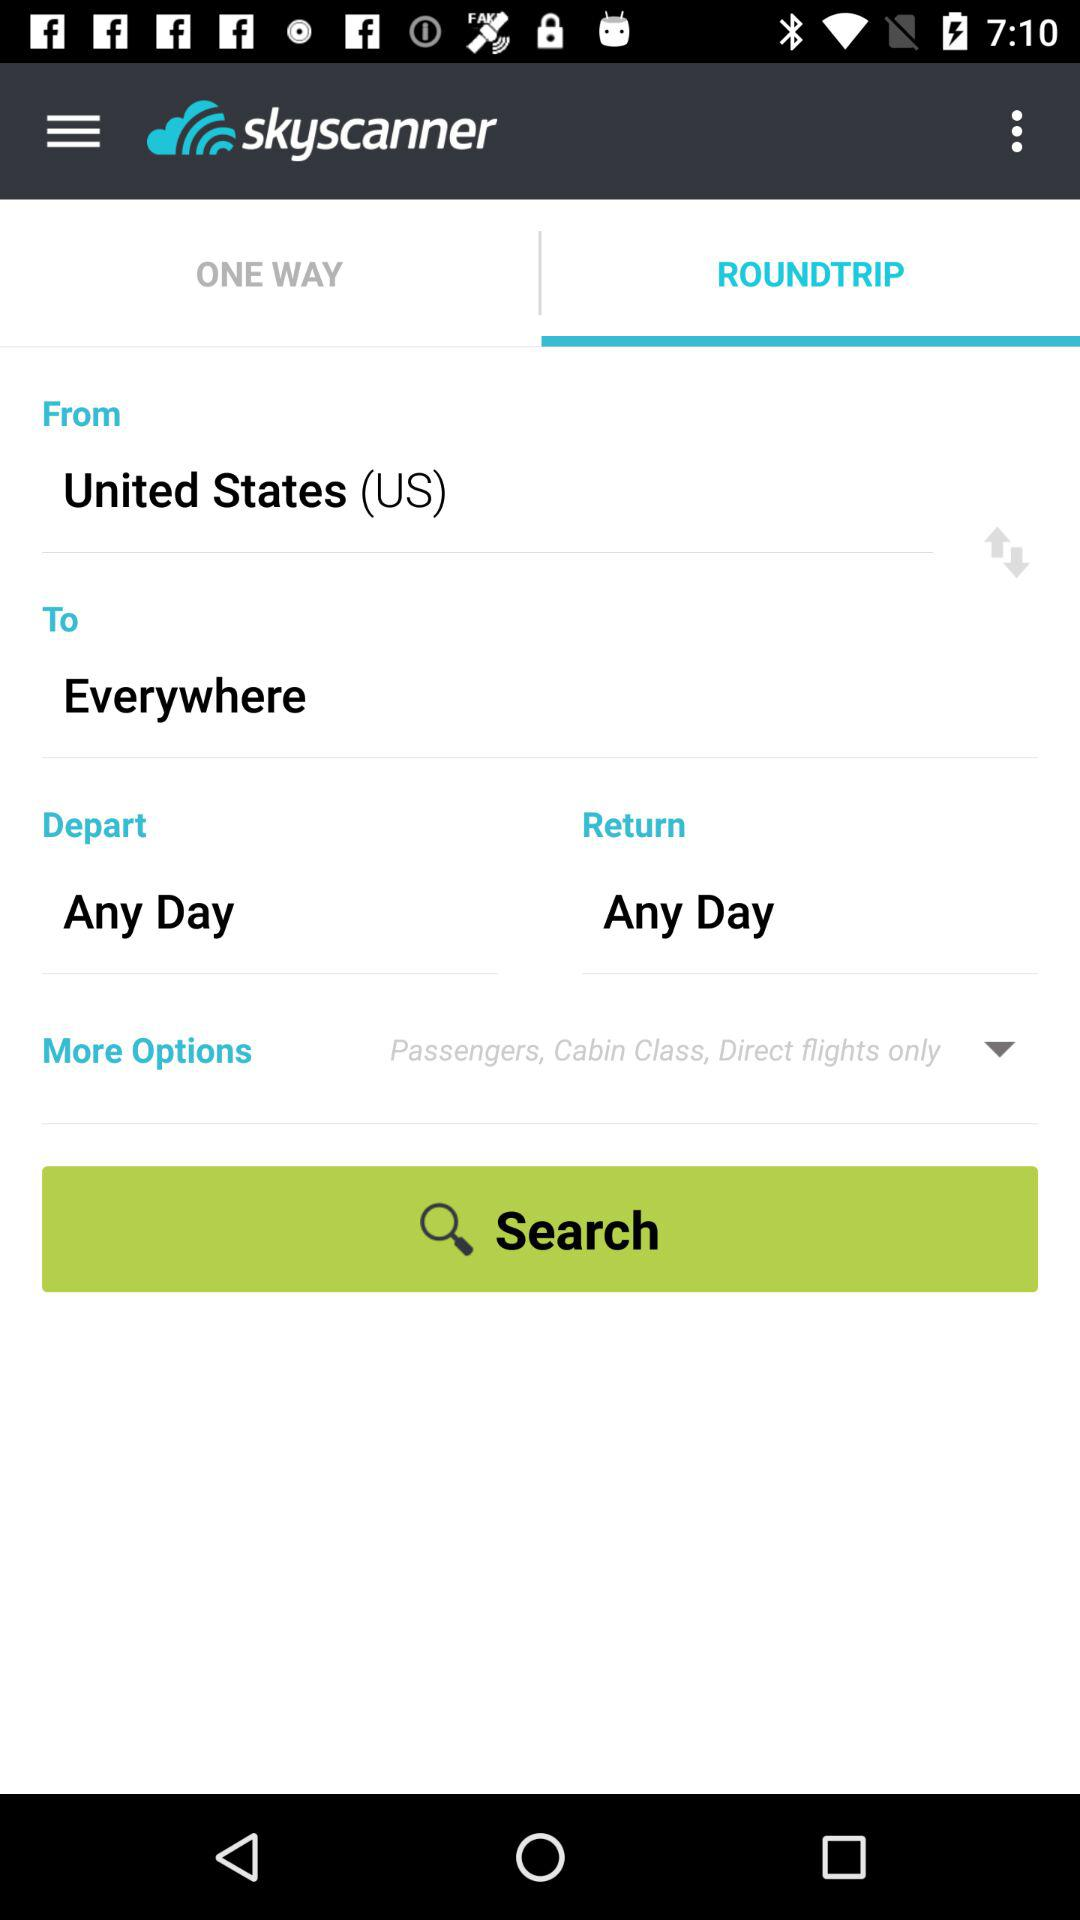Which tab is selected? The selected tab is "ROUNDTRIP". 